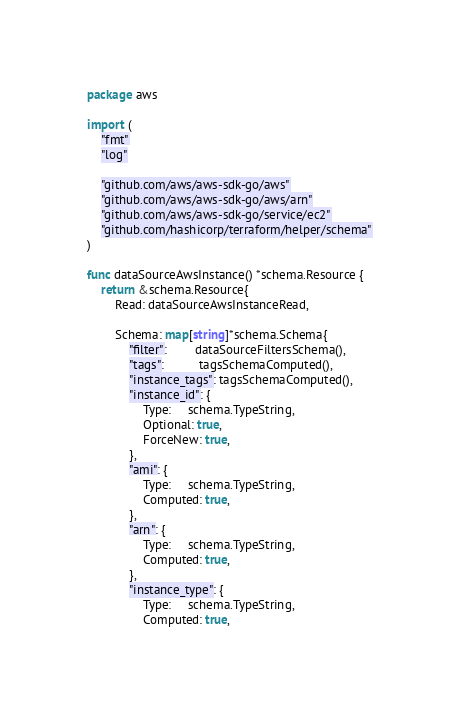Convert code to text. <code><loc_0><loc_0><loc_500><loc_500><_Go_>package aws

import (
	"fmt"
	"log"

	"github.com/aws/aws-sdk-go/aws"
	"github.com/aws/aws-sdk-go/aws/arn"
	"github.com/aws/aws-sdk-go/service/ec2"
	"github.com/hashicorp/terraform/helper/schema"
)

func dataSourceAwsInstance() *schema.Resource {
	return &schema.Resource{
		Read: dataSourceAwsInstanceRead,

		Schema: map[string]*schema.Schema{
			"filter":        dataSourceFiltersSchema(),
			"tags":          tagsSchemaComputed(),
			"instance_tags": tagsSchemaComputed(),
			"instance_id": {
				Type:     schema.TypeString,
				Optional: true,
				ForceNew: true,
			},
			"ami": {
				Type:     schema.TypeString,
				Computed: true,
			},
			"arn": {
				Type:     schema.TypeString,
				Computed: true,
			},
			"instance_type": {
				Type:     schema.TypeString,
				Computed: true,</code> 